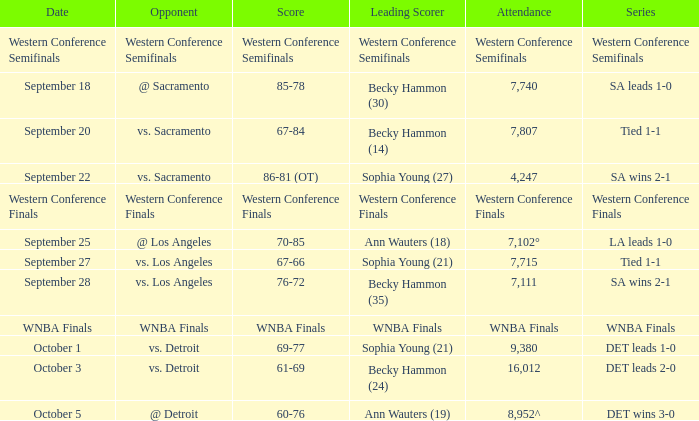What is the attendance of the western conference finals series? Western Conference Finals. 